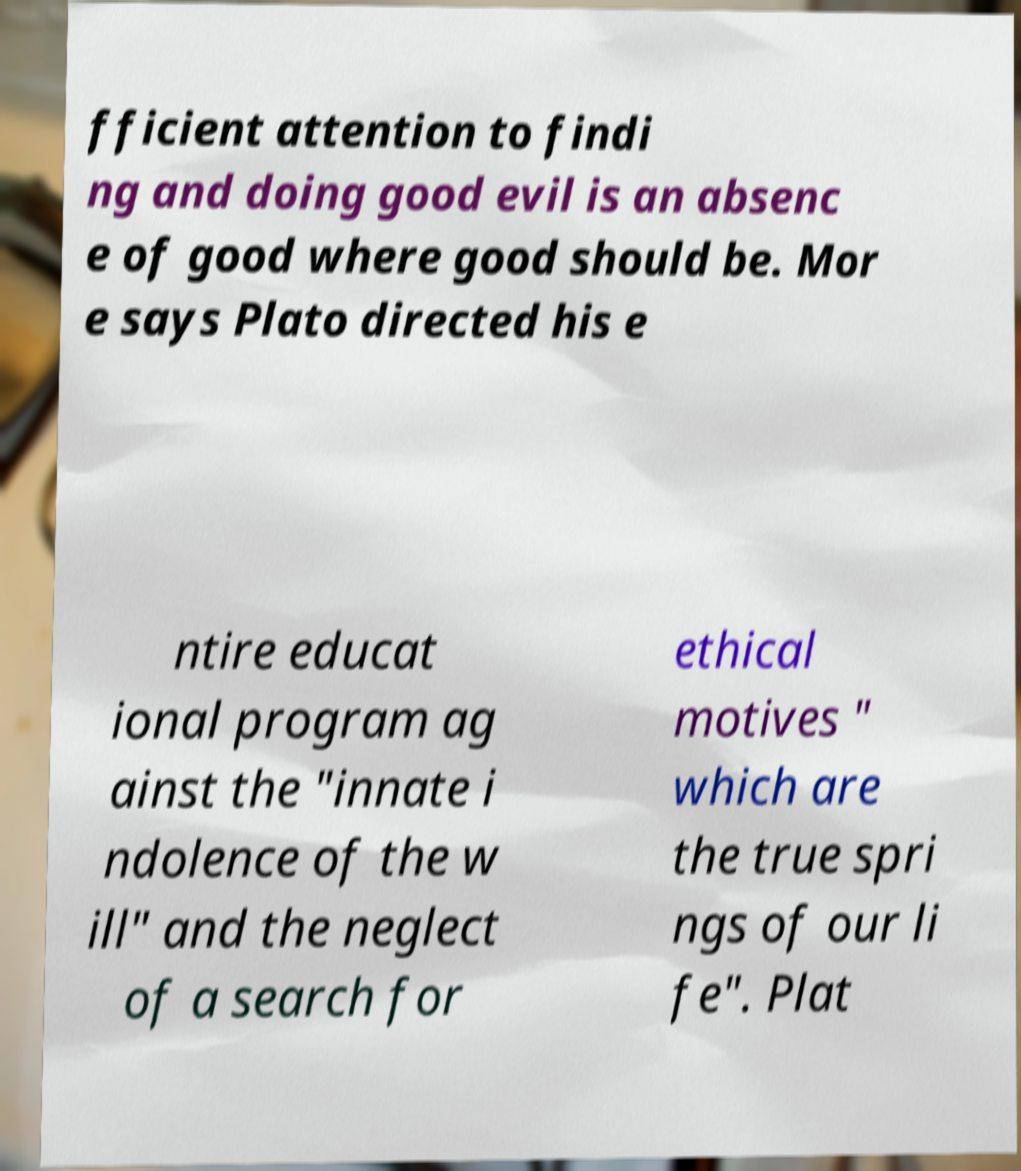For documentation purposes, I need the text within this image transcribed. Could you provide that? fficient attention to findi ng and doing good evil is an absenc e of good where good should be. Mor e says Plato directed his e ntire educat ional program ag ainst the "innate i ndolence of the w ill" and the neglect of a search for ethical motives " which are the true spri ngs of our li fe". Plat 